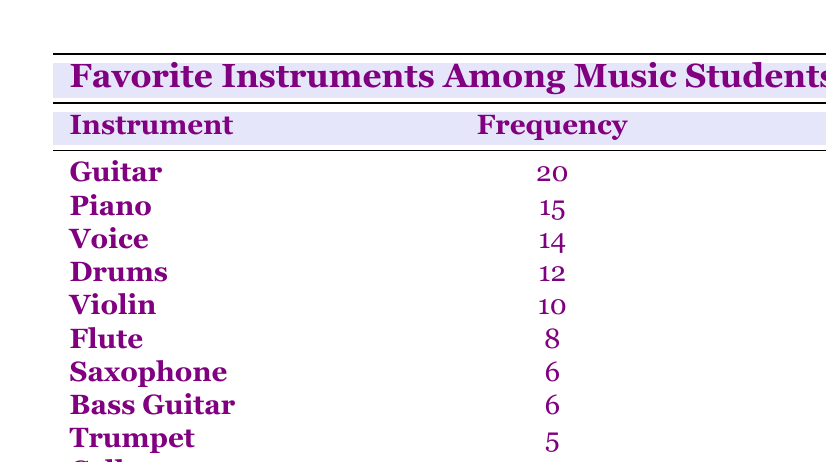What is the most popular instrument among the music students? The table lists the frequencies for each instrument. The "Guitar" has the highest frequency at 20.
Answer: Guitar How many students prefer the Piano? The frequency for "Piano" in the table indicates that 15 students chose it as their favorite instrument.
Answer: 15 Which instruments have a frequency of 6? According to the table, both "Saxophone" and "Bass Guitar" have a frequency of 6.
Answer: Saxophone and Bass Guitar What is the total number of students who listed their favorite instrument? To find the total, sum all the frequencies: 20 + 15 + 14 + 12 + 10 + 8 + 6 + 6 + 5 + 4 = 100. Therefore, the total number of students is 100.
Answer: 100 Is the Violin more popular than the Flute? The frequency for "Violin" is 10 and for "Flute" it is 8. Since 10 is greater than 8, the Violin is indeed more popular than the Flute.
Answer: Yes What is the average frequency of the instruments listed? To find the average, first sum all frequencies: 100 (as calculated previously), then divide by the number of instruments (10). The average is 100/10 = 10.
Answer: 10 How many more students prefer the Guitar than the Cello? The frequency for "Guitar" is 20, and for "Cello" it is 4. The difference is 20 - 4 = 16. Thus, 16 more students prefer the Guitar than the Cello.
Answer: 16 Is there an instrument that fewer than 5 students like? The minimum frequency listed in the table is for "Cello," which has a frequency of 4. Therefore, yes, there is an instrument that fewer than 5 students like.
Answer: Yes Which instruments combined have a frequency greater than 30? "Guitar" (20) + "Piano" (15) = 35, which is greater than 30. Also, "Voice" (14) + "Drums" (12) = 26, but when combined with "Guitar" it exceeds 30. Specifically, Guitar and Piano can be combined to exceed 30.
Answer: Guitar and Piano 